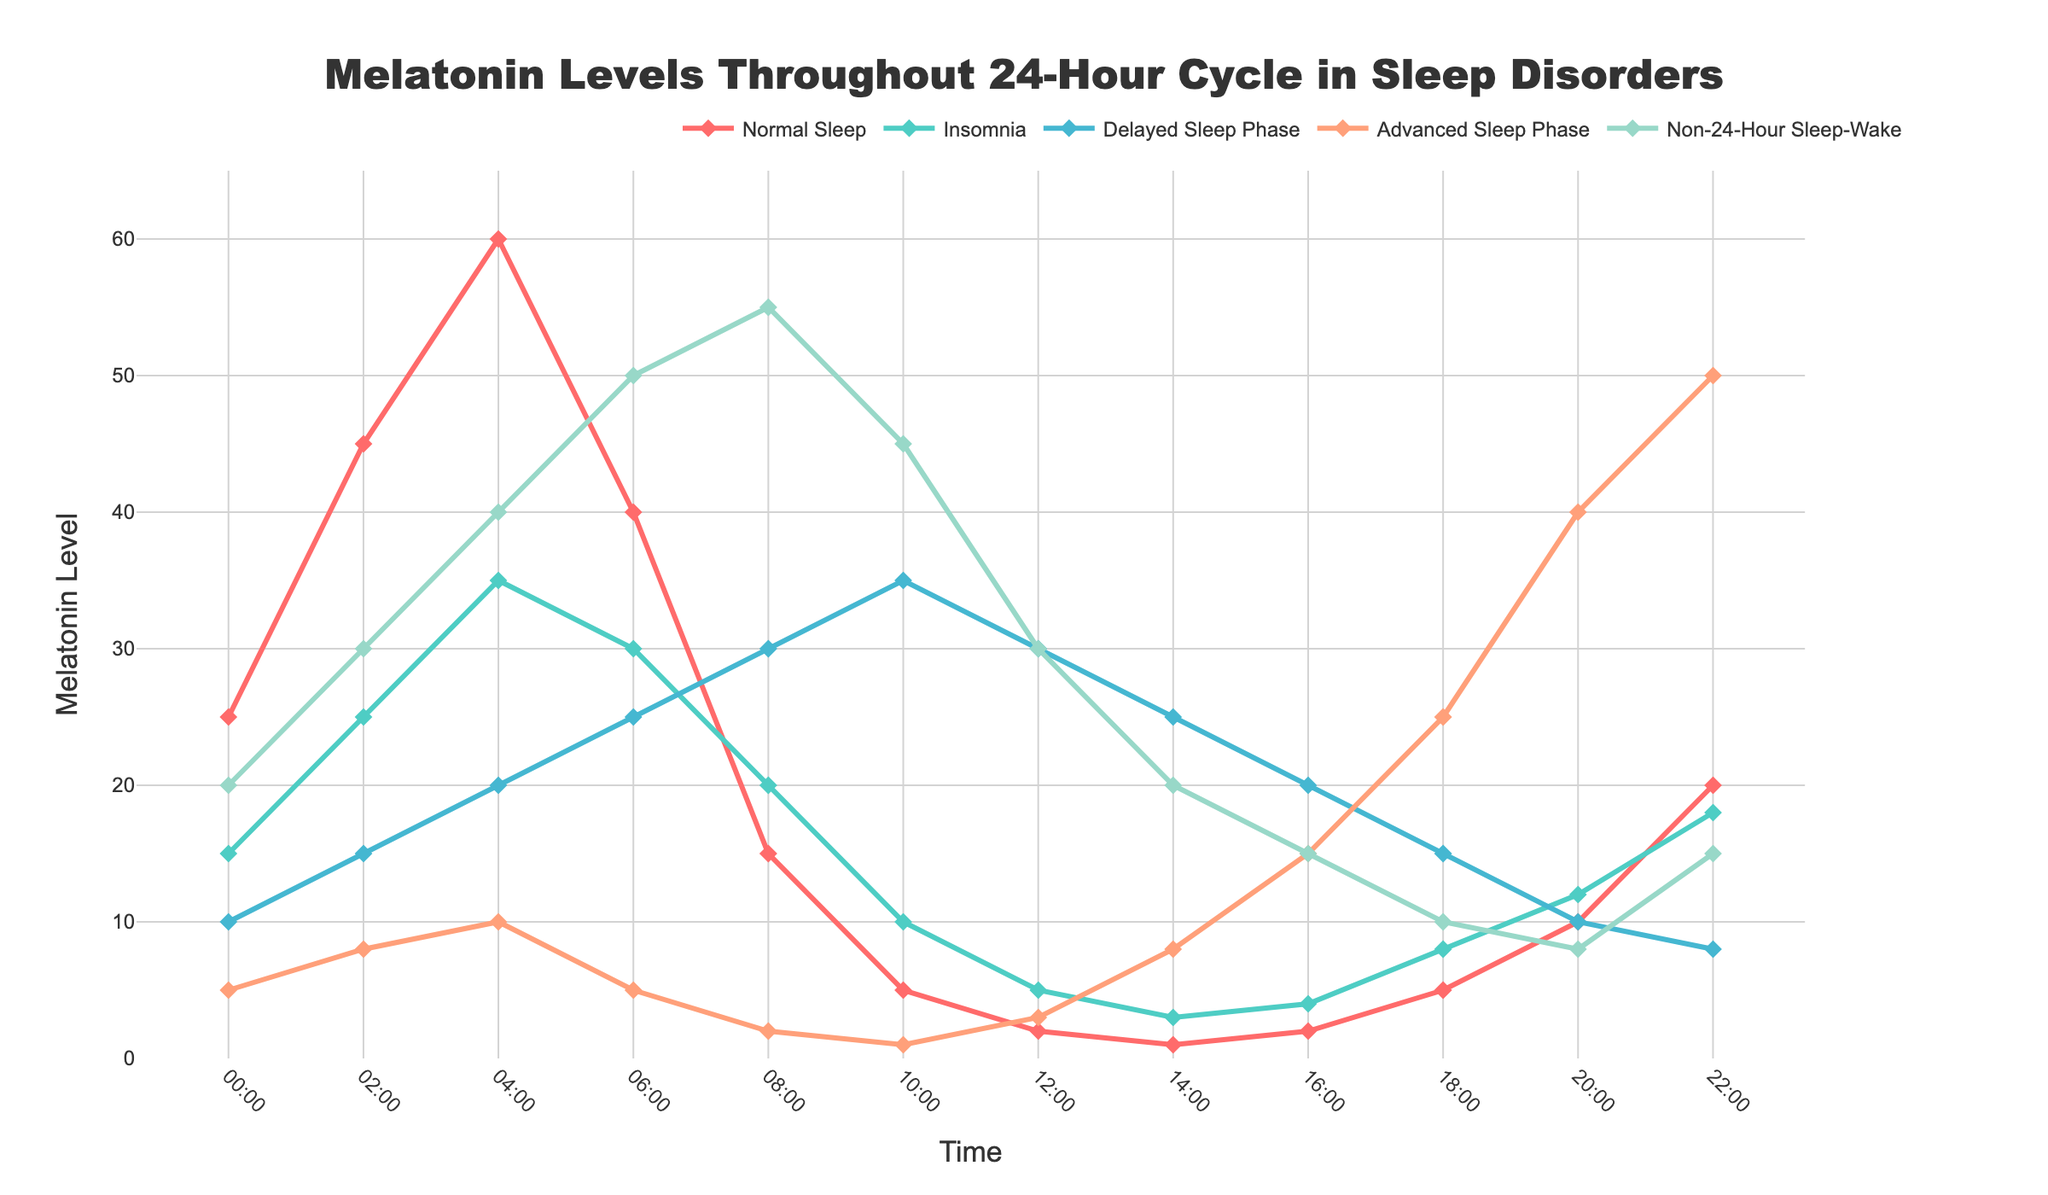What time does the highest melatonin level occur for Normal Sleep? Look for the peak point on the line representing Normal Sleep and identify the corresponding time on the x-axis.
Answer: 04:00 How does the melatonin level at 08:00 for Delayed Sleep Phase compare to the one at 08:00 for Normal Sleep? Locate the melatonin levels for Delayed Sleep Phase and Normal Sleep at 08:00 on the y-axis and compare them numerically.
Answer: Higher Which sleep disorder exhibits the lowest melatonin level at 14:00? Identify which line has the lowest point at 14:00 on the y-axis.
Answer: Normal Sleep What is the average melatonin level at 02:00 for all sleep disorders? Add the melatonin levels at 02:00 for all disorders (25 + 15 + 8 + 30 + 45 = 123) and divide by the number of disorders (5).
Answer: 24.6 Between Advanced Sleep Phase and Non-24-Hour Sleep-Wake, which disorder shows a steeper increase in melatonin levels from 18:00 to 22:00? Compare the slopes of the lines representing Advanced Sleep Phase and Non-24-Hour Sleep-Wake between 18:00 and 22:00.
Answer: Advanced Sleep Phase What is the total melatonin level for Insomnia from 00:00 to 04:00? Add the melatonin levels for Insomnia at 00:00, 02:00, and 04:00 (15 + 25 + 35 = 75).
Answer: 75 Which sleep disorder shows the widest range of melatonin levels throughout the 24-hour cycle? Find the difference between the highest and lowest melatonin levels for each disorder and compare them.
Answer: Normal Sleep How do melatonin levels at 12:00 for Advanced Sleep Phase and Non-24-Hour Sleep-Wake compare? Locate the melatonin levels for Advanced Sleep Phase and Non-24-Hour Sleep-Wake at 12:00 and compare them numerically.
Answer: Advanced Sleep Phase is lower What trend is observed in melatonin levels for Non-24-Hour Sleep-Wake between 06:00 and 10:00? Examine the changes in melatonin levels for Non-24-Hour Sleep-Wake in the specified time interval.
Answer: Increasing What is the difference in melatonin levels for Insomnia and Delayed Sleep Phase at 18:00? Subtract the melatonin level of Delayed Sleep Phase at 18:00 from that of Insomnia at the same time (8 - 8 = 0).
Answer: 0 